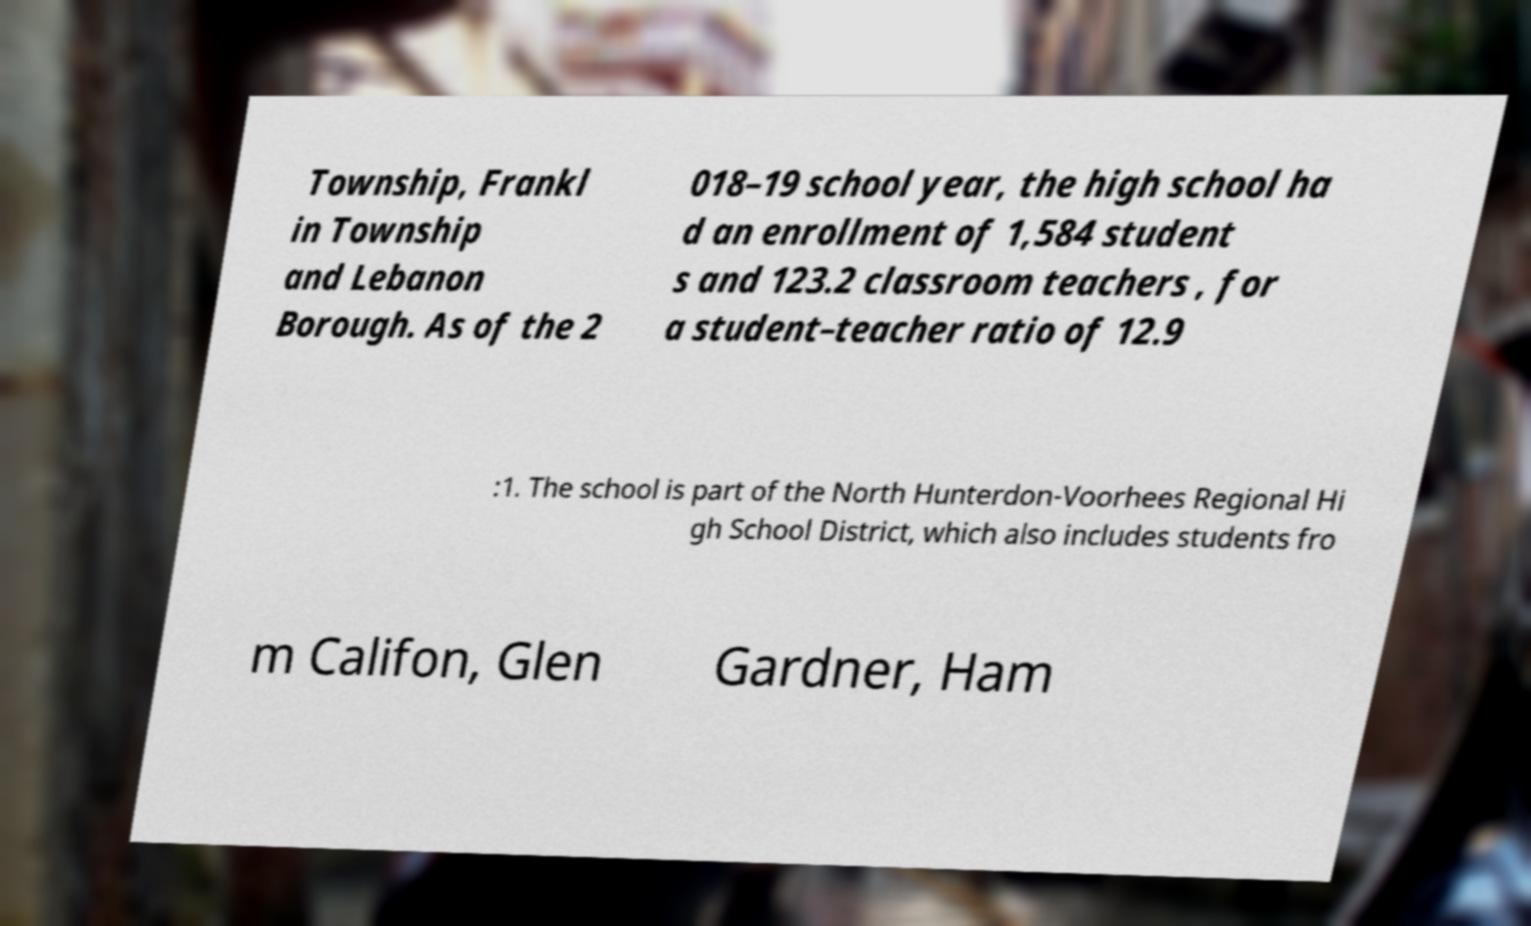What messages or text are displayed in this image? I need them in a readable, typed format. Township, Frankl in Township and Lebanon Borough. As of the 2 018–19 school year, the high school ha d an enrollment of 1,584 student s and 123.2 classroom teachers , for a student–teacher ratio of 12.9 :1. The school is part of the North Hunterdon-Voorhees Regional Hi gh School District, which also includes students fro m Califon, Glen Gardner, Ham 